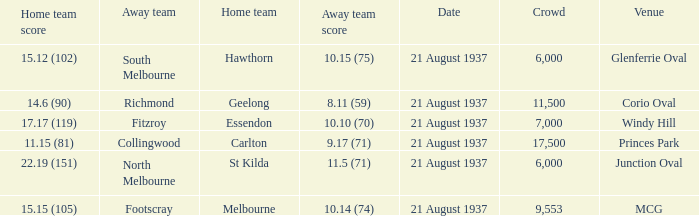Where does South Melbourne play? Glenferrie Oval. 